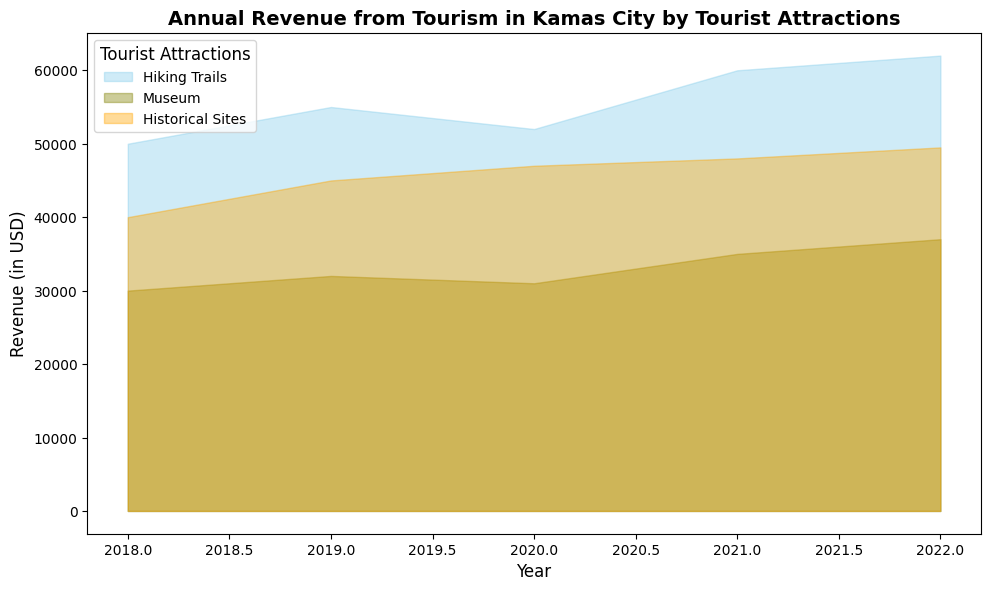Which tourist attraction generated the highest revenue in 2022? Look at the different area segments for 2022; the one with the largest height represents the highest revenue. Hiking Trails has the highest height in 2022.
Answer: Hiking Trails How much total revenue was generated by Historical Sites between 2018 and 2022? Sum the revenue values for Historical Sites from 2018 to 2022: 40000 + 45000 + 47000 + 48000 + 49500 = 229500.
Answer: 229500 Which year saw the highest overall revenue for Hiking Trails? Compare the heights of the Hiking Trails areas across all years; 2022 is the tallest.
Answer: 2022 By how much did the revenue from the Museum increase from 2018 to 2022? Calculate the difference in revenue for the Museum between 2018 and 2022: 37000 - 30000 = 7000.
Answer: 7000 Which tourist attraction has the most consistent annual revenue from 2018 to 2022? Look for the tourist attraction with the smallest variation in the height of areas over the years. The Museum has the smallest variation visually.
Answer: Museum In which year did Historical Sites first outperform Museum in revenue? Compare the heights of the Historical Sites and Museum year by year; 2019 is the first year Historical Sites are taller than the Museum area.
Answer: 2019 Calculate the average annual revenue for Hiking Trails from 2018 to 2022. Sum the revenues for Hiking Trails: 50000 + 55000 + 52000 + 60000 + 62000 = 279000. Then, divide by the number of years: 279000 / 5 = 55800.
Answer: 55800 Which tourist attraction had the lowest revenue in 2020? Identify the smallest area segment for 2020; the Museum area is the smallest.
Answer: Museum How did the total revenue from all attractions combined change from 2018 to 2019? Calculate the total revenue for both years and find the difference: (50000+30000+40000) = 120000 for 2018 and (55000+32000+45000) = 132000 for 2019. The change is 132000 - 120000 = 12000.
Answer: 12000 What is the revenue difference between Hiking Trails and Historical Sites in 2021? Subtract the revenue of Historical Sites from Hiking Trails in 2021: 60000 - 48000 = 12000.
Answer: 12000 